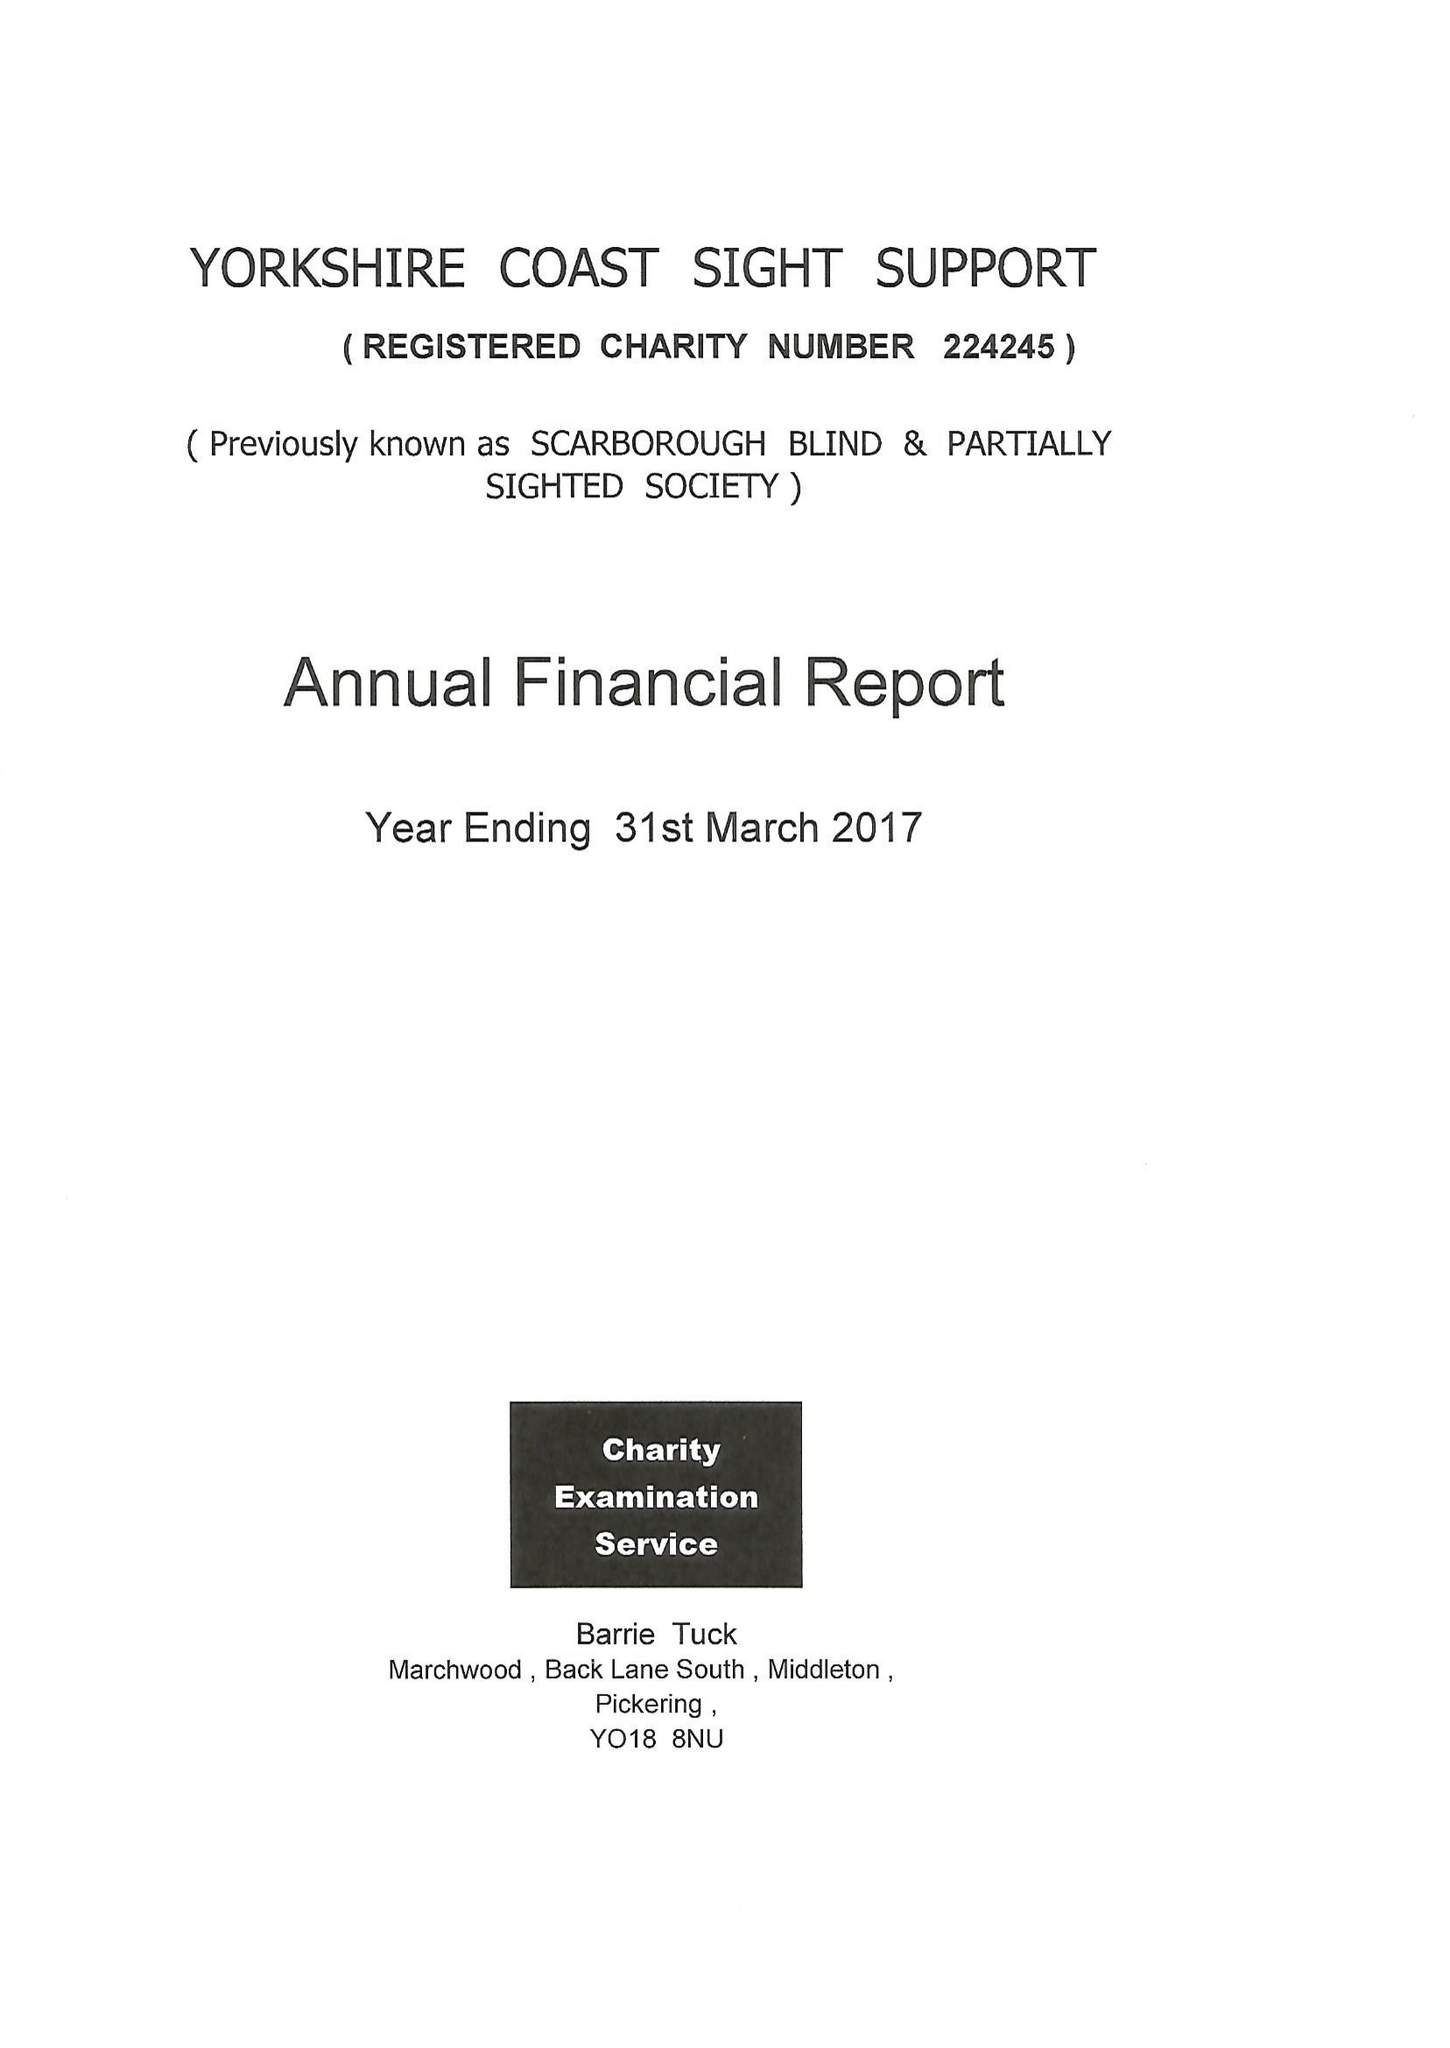What is the value for the address__street_line?
Answer the question using a single word or phrase. 181-183 DEAN ROAD 